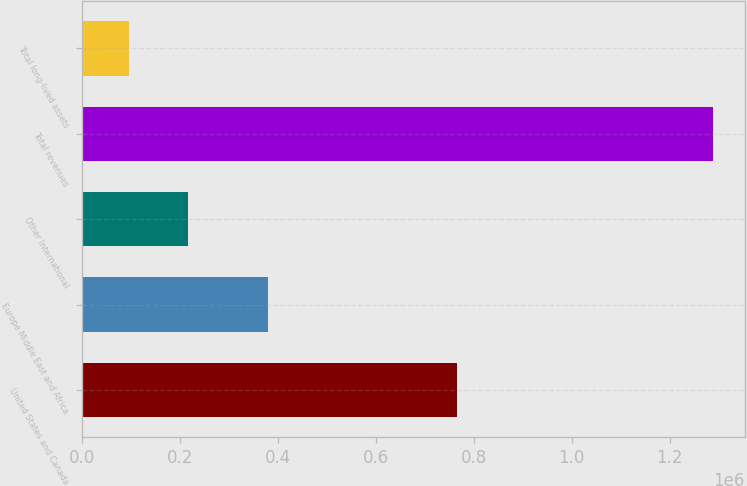Convert chart to OTSL. <chart><loc_0><loc_0><loc_500><loc_500><bar_chart><fcel>United States and Canada<fcel>Europe Middle East and Africa<fcel>Other International<fcel>Total revenues<fcel>Total long-lived assets<nl><fcel>765793<fcel>380771<fcel>216320<fcel>1.28845e+06<fcel>97194<nl></chart> 